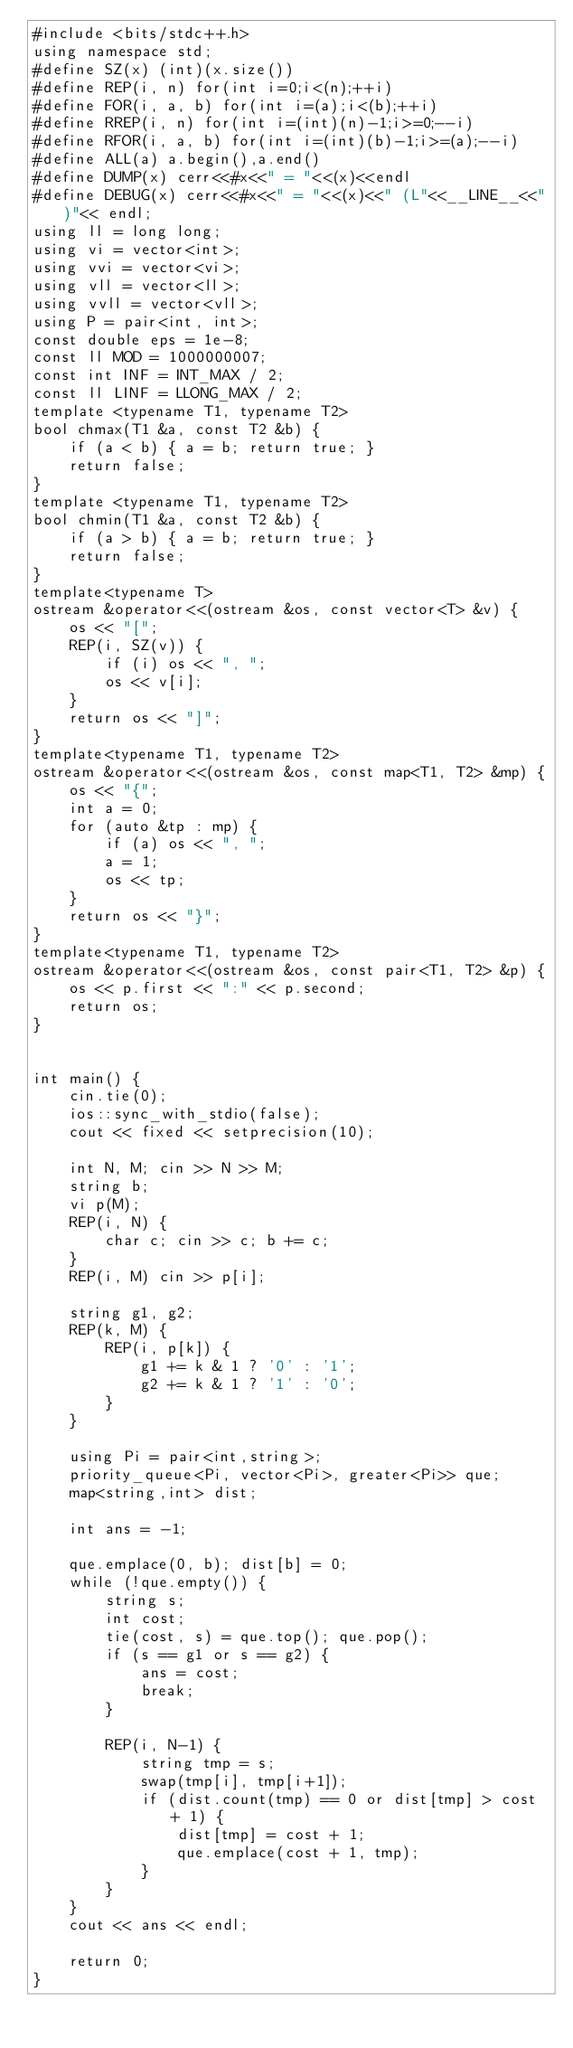<code> <loc_0><loc_0><loc_500><loc_500><_C++_>#include <bits/stdc++.h>
using namespace std;
#define SZ(x) (int)(x.size())
#define REP(i, n) for(int i=0;i<(n);++i)
#define FOR(i, a, b) for(int i=(a);i<(b);++i)
#define RREP(i, n) for(int i=(int)(n)-1;i>=0;--i)
#define RFOR(i, a, b) for(int i=(int)(b)-1;i>=(a);--i)
#define ALL(a) a.begin(),a.end()
#define DUMP(x) cerr<<#x<<" = "<<(x)<<endl
#define DEBUG(x) cerr<<#x<<" = "<<(x)<<" (L"<<__LINE__<<")"<< endl;
using ll = long long;
using vi = vector<int>;
using vvi = vector<vi>;
using vll = vector<ll>;
using vvll = vector<vll>;
using P = pair<int, int>;
const double eps = 1e-8;
const ll MOD = 1000000007;
const int INF = INT_MAX / 2;
const ll LINF = LLONG_MAX / 2;
template <typename T1, typename T2>
bool chmax(T1 &a, const T2 &b) {
    if (a < b) { a = b; return true; }
    return false;
}
template <typename T1, typename T2>
bool chmin(T1 &a, const T2 &b) {
    if (a > b) { a = b; return true; }
    return false;
}
template<typename T>
ostream &operator<<(ostream &os, const vector<T> &v) {
    os << "[";
    REP(i, SZ(v)) {
        if (i) os << ", ";
        os << v[i];
    }
    return os << "]";
}
template<typename T1, typename T2>
ostream &operator<<(ostream &os, const map<T1, T2> &mp) {
    os << "{";
    int a = 0;
    for (auto &tp : mp) {
        if (a) os << ", ";
        a = 1;
        os << tp;
    }
    return os << "}";
}
template<typename T1, typename T2>
ostream &operator<<(ostream &os, const pair<T1, T2> &p) {
    os << p.first << ":" << p.second;
    return os;
}


int main() {
    cin.tie(0);
    ios::sync_with_stdio(false);
    cout << fixed << setprecision(10);

    int N, M; cin >> N >> M;
    string b;
    vi p(M);
    REP(i, N) {
        char c; cin >> c; b += c;
    }
    REP(i, M) cin >> p[i];

    string g1, g2;
    REP(k, M) {
        REP(i, p[k]) {
            g1 += k & 1 ? '0' : '1';
            g2 += k & 1 ? '1' : '0';
        }
    }

    using Pi = pair<int,string>;
    priority_queue<Pi, vector<Pi>, greater<Pi>> que;
    map<string,int> dist;

    int ans = -1;

    que.emplace(0, b); dist[b] = 0;
    while (!que.empty()) {
        string s;
        int cost;
        tie(cost, s) = que.top(); que.pop();
        if (s == g1 or s == g2) {
            ans = cost;
            break;
        }

        REP(i, N-1) {
            string tmp = s;
            swap(tmp[i], tmp[i+1]);
            if (dist.count(tmp) == 0 or dist[tmp] > cost + 1) {
                dist[tmp] = cost + 1;
                que.emplace(cost + 1, tmp);
            }
        }
    }
    cout << ans << endl;

    return 0;
}

</code> 